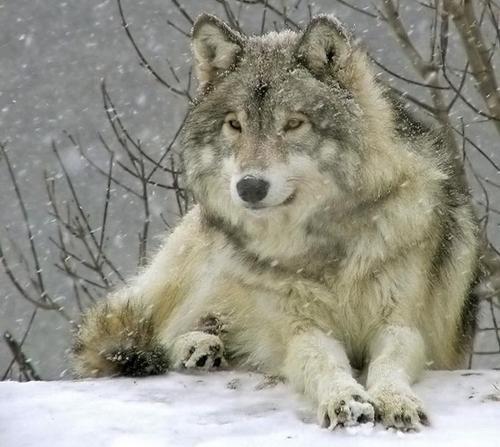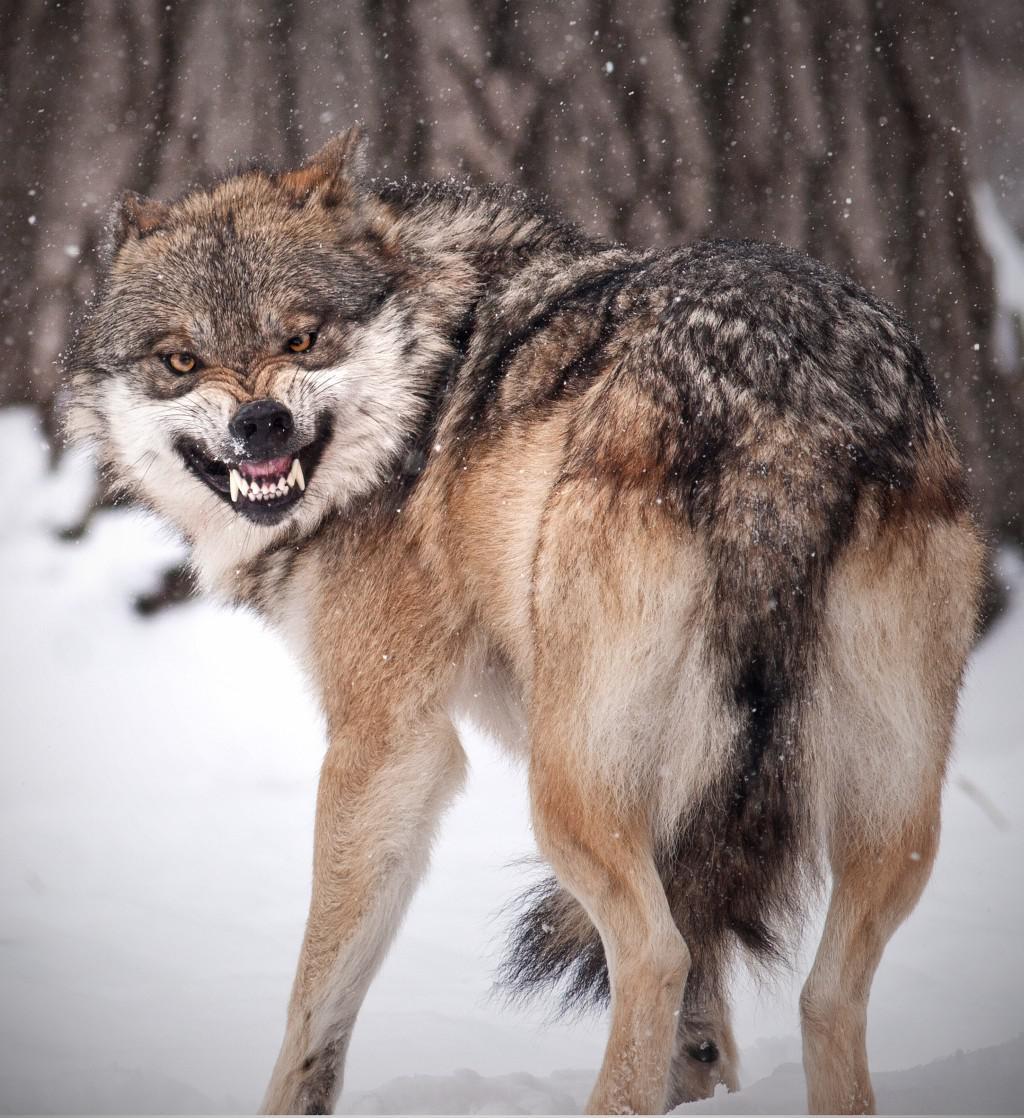The first image is the image on the left, the second image is the image on the right. Given the left and right images, does the statement "The left-hand image shows a wolf that is not standing on all fours." hold true? Answer yes or no. Yes. 